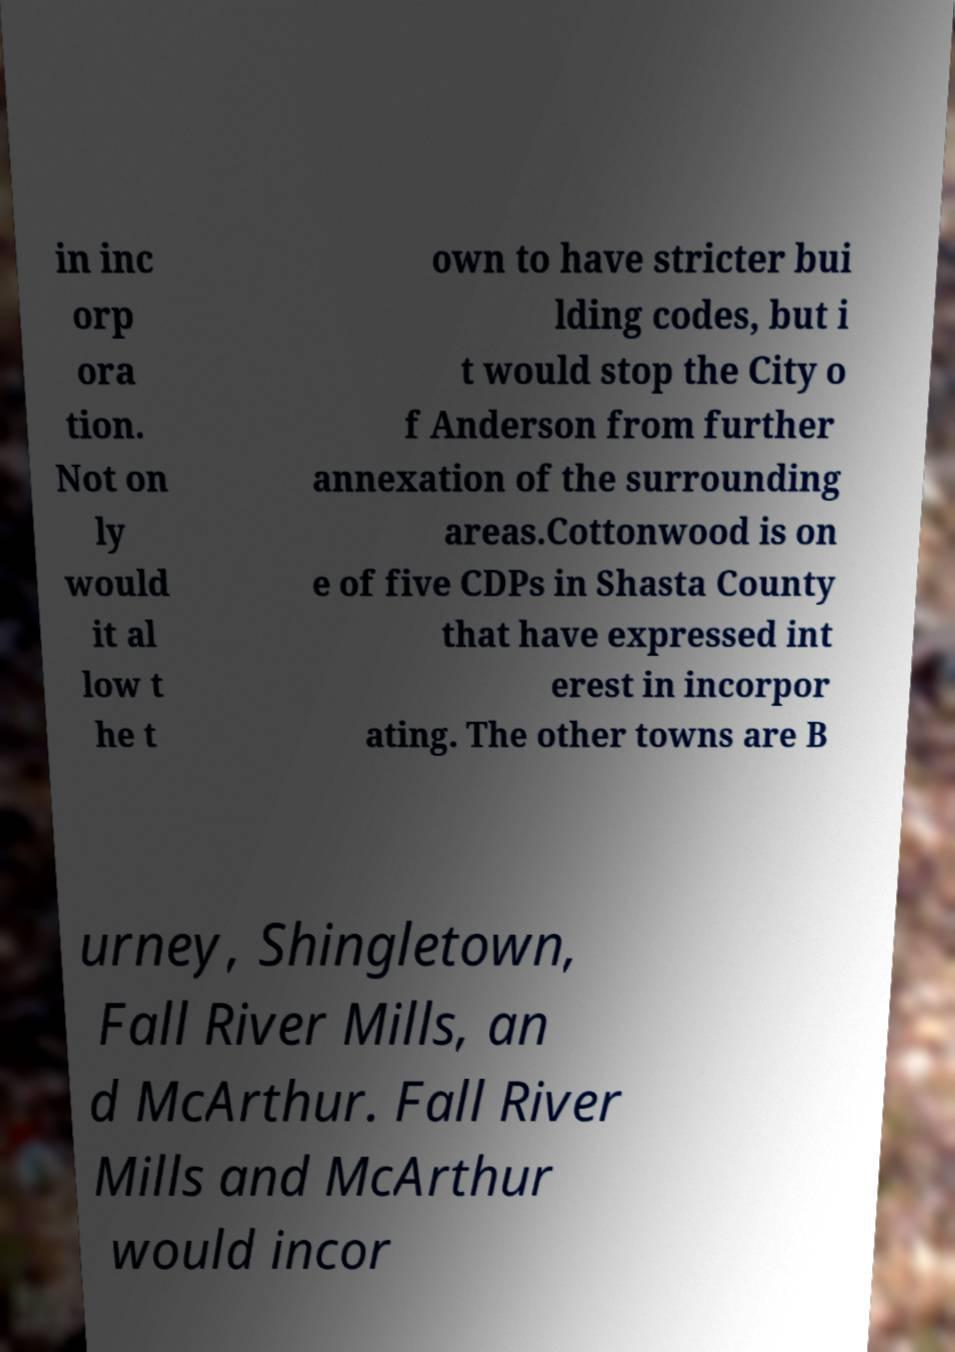I need the written content from this picture converted into text. Can you do that? in inc orp ora tion. Not on ly would it al low t he t own to have stricter bui lding codes, but i t would stop the City o f Anderson from further annexation of the surrounding areas.Cottonwood is on e of five CDPs in Shasta County that have expressed int erest in incorpor ating. The other towns are B urney, Shingletown, Fall River Mills, an d McArthur. Fall River Mills and McArthur would incor 